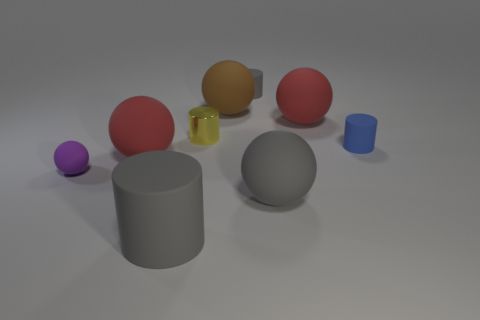Subtract all yellow cylinders. How many cylinders are left? 3 Subtract 2 cylinders. How many cylinders are left? 2 Subtract all small purple spheres. How many spheres are left? 4 Add 1 tiny purple matte spheres. How many objects exist? 10 Subtract all red cylinders. Subtract all gray balls. How many cylinders are left? 4 Add 9 green cylinders. How many green cylinders exist? 9 Subtract 2 gray cylinders. How many objects are left? 7 Subtract all cylinders. How many objects are left? 5 Subtract all large red rubber spheres. Subtract all gray matte cylinders. How many objects are left? 5 Add 3 tiny purple rubber objects. How many tiny purple rubber objects are left? 4 